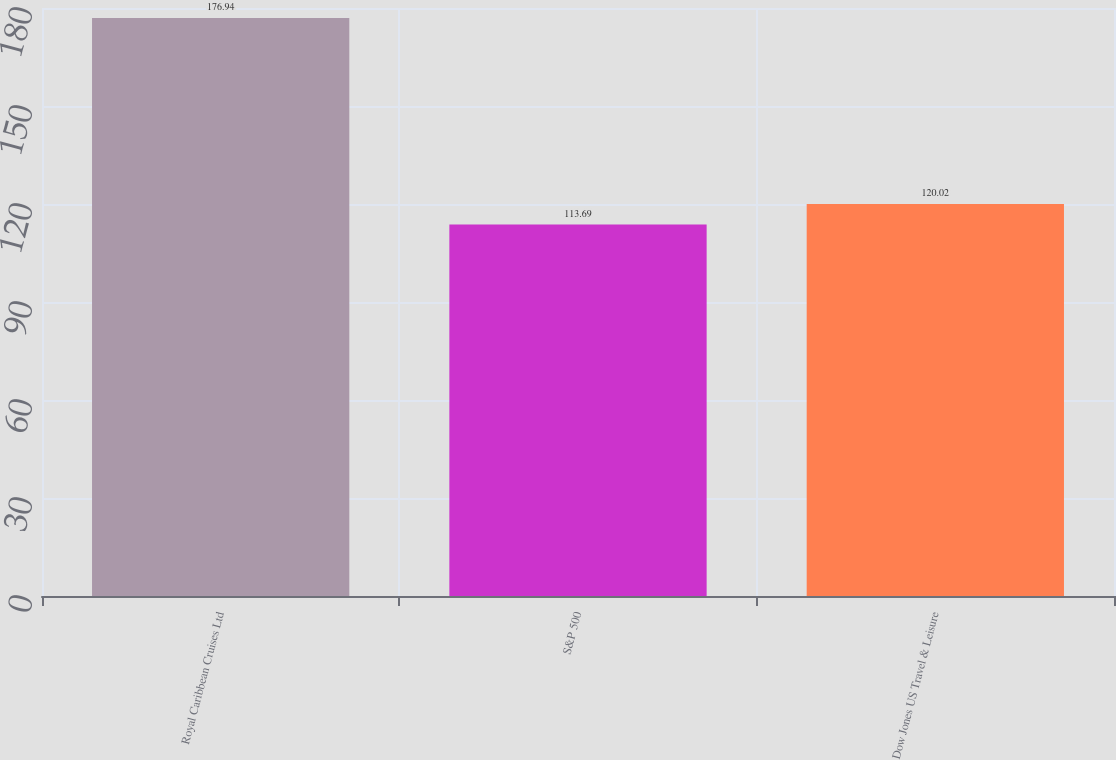Convert chart to OTSL. <chart><loc_0><loc_0><loc_500><loc_500><bar_chart><fcel>Royal Caribbean Cruises Ltd<fcel>S&P 500<fcel>Dow Jones US Travel & Leisure<nl><fcel>176.94<fcel>113.69<fcel>120.02<nl></chart> 